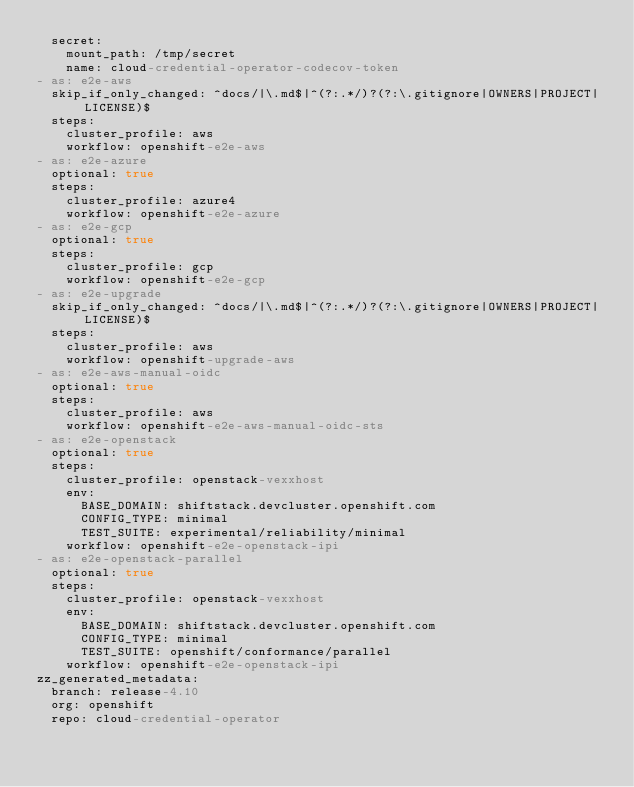<code> <loc_0><loc_0><loc_500><loc_500><_YAML_>  secret:
    mount_path: /tmp/secret
    name: cloud-credential-operator-codecov-token
- as: e2e-aws
  skip_if_only_changed: ^docs/|\.md$|^(?:.*/)?(?:\.gitignore|OWNERS|PROJECT|LICENSE)$
  steps:
    cluster_profile: aws
    workflow: openshift-e2e-aws
- as: e2e-azure
  optional: true
  steps:
    cluster_profile: azure4
    workflow: openshift-e2e-azure
- as: e2e-gcp
  optional: true
  steps:
    cluster_profile: gcp
    workflow: openshift-e2e-gcp
- as: e2e-upgrade
  skip_if_only_changed: ^docs/|\.md$|^(?:.*/)?(?:\.gitignore|OWNERS|PROJECT|LICENSE)$
  steps:
    cluster_profile: aws
    workflow: openshift-upgrade-aws
- as: e2e-aws-manual-oidc
  optional: true
  steps:
    cluster_profile: aws
    workflow: openshift-e2e-aws-manual-oidc-sts
- as: e2e-openstack
  optional: true
  steps:
    cluster_profile: openstack-vexxhost
    env:
      BASE_DOMAIN: shiftstack.devcluster.openshift.com
      CONFIG_TYPE: minimal
      TEST_SUITE: experimental/reliability/minimal
    workflow: openshift-e2e-openstack-ipi
- as: e2e-openstack-parallel
  optional: true
  steps:
    cluster_profile: openstack-vexxhost
    env:
      BASE_DOMAIN: shiftstack.devcluster.openshift.com
      CONFIG_TYPE: minimal
      TEST_SUITE: openshift/conformance/parallel
    workflow: openshift-e2e-openstack-ipi
zz_generated_metadata:
  branch: release-4.10
  org: openshift
  repo: cloud-credential-operator
</code> 